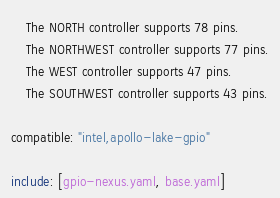Convert code to text. <code><loc_0><loc_0><loc_500><loc_500><_YAML_>    The NORTH controller supports 78 pins.
    The NORTHWEST controller supports 77 pins.
    The WEST controller supports 47 pins.
    The SOUTHWEST controller supports 43 pins.

compatible: "intel,apollo-lake-gpio"

include: [gpio-nexus.yaml, base.yaml]
</code> 